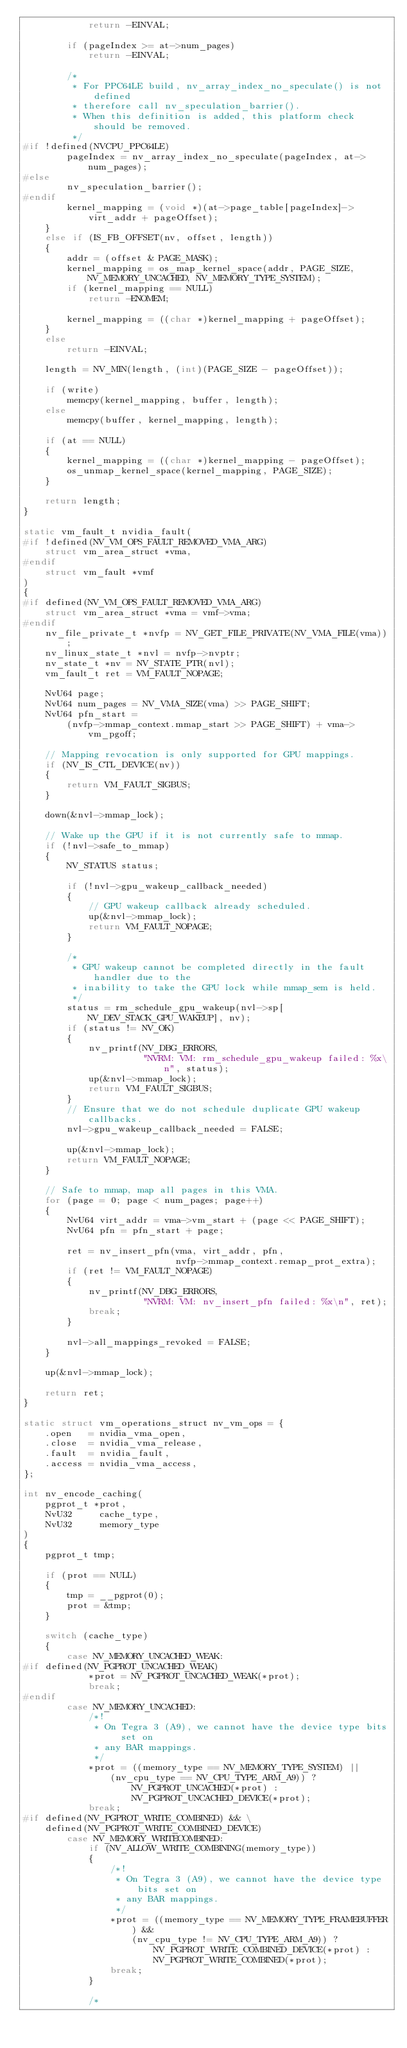Convert code to text. <code><loc_0><loc_0><loc_500><loc_500><_C_>            return -EINVAL;

        if (pageIndex >= at->num_pages)
            return -EINVAL;

        /*
         * For PPC64LE build, nv_array_index_no_speculate() is not defined
         * therefore call nv_speculation_barrier().
         * When this definition is added, this platform check should be removed.
         */
#if !defined(NVCPU_PPC64LE)
        pageIndex = nv_array_index_no_speculate(pageIndex, at->num_pages);
#else
        nv_speculation_barrier();
#endif
        kernel_mapping = (void *)(at->page_table[pageIndex]->virt_addr + pageOffset);
    }
    else if (IS_FB_OFFSET(nv, offset, length))
    {
        addr = (offset & PAGE_MASK);
        kernel_mapping = os_map_kernel_space(addr, PAGE_SIZE, NV_MEMORY_UNCACHED, NV_MEMORY_TYPE_SYSTEM);
        if (kernel_mapping == NULL)
            return -ENOMEM;

        kernel_mapping = ((char *)kernel_mapping + pageOffset);
    }
    else
        return -EINVAL;

    length = NV_MIN(length, (int)(PAGE_SIZE - pageOffset));

    if (write)
        memcpy(kernel_mapping, buffer, length);
    else
        memcpy(buffer, kernel_mapping, length);

    if (at == NULL)
    {
        kernel_mapping = ((char *)kernel_mapping - pageOffset);
        os_unmap_kernel_space(kernel_mapping, PAGE_SIZE);
    }

    return length;
}

static vm_fault_t nvidia_fault(
#if !defined(NV_VM_OPS_FAULT_REMOVED_VMA_ARG)
    struct vm_area_struct *vma,
#endif
    struct vm_fault *vmf
)
{
#if defined(NV_VM_OPS_FAULT_REMOVED_VMA_ARG)
    struct vm_area_struct *vma = vmf->vma;
#endif
    nv_file_private_t *nvfp = NV_GET_FILE_PRIVATE(NV_VMA_FILE(vma));
    nv_linux_state_t *nvl = nvfp->nvptr;
    nv_state_t *nv = NV_STATE_PTR(nvl);
    vm_fault_t ret = VM_FAULT_NOPAGE;

    NvU64 page;
    NvU64 num_pages = NV_VMA_SIZE(vma) >> PAGE_SHIFT;
    NvU64 pfn_start =
        (nvfp->mmap_context.mmap_start >> PAGE_SHIFT) + vma->vm_pgoff;

    // Mapping revocation is only supported for GPU mappings.
    if (NV_IS_CTL_DEVICE(nv))
    {
        return VM_FAULT_SIGBUS;
    }

    down(&nvl->mmap_lock);

    // Wake up the GPU if it is not currently safe to mmap.
    if (!nvl->safe_to_mmap)
    {
        NV_STATUS status;

        if (!nvl->gpu_wakeup_callback_needed)
        {
            // GPU wakeup callback already scheduled.
            up(&nvl->mmap_lock);
            return VM_FAULT_NOPAGE;
        }

        /*
         * GPU wakeup cannot be completed directly in the fault handler due to the
         * inability to take the GPU lock while mmap_sem is held.
         */
        status = rm_schedule_gpu_wakeup(nvl->sp[NV_DEV_STACK_GPU_WAKEUP], nv);
        if (status != NV_OK)
        {
            nv_printf(NV_DBG_ERRORS,
                      "NVRM: VM: rm_schedule_gpu_wakeup failed: %x\n", status);
            up(&nvl->mmap_lock);
            return VM_FAULT_SIGBUS;
        }
        // Ensure that we do not schedule duplicate GPU wakeup callbacks.
        nvl->gpu_wakeup_callback_needed = FALSE;

        up(&nvl->mmap_lock);
        return VM_FAULT_NOPAGE;
    }

    // Safe to mmap, map all pages in this VMA.
    for (page = 0; page < num_pages; page++)
    {
        NvU64 virt_addr = vma->vm_start + (page << PAGE_SHIFT);
        NvU64 pfn = pfn_start + page;

        ret = nv_insert_pfn(vma, virt_addr, pfn,
                            nvfp->mmap_context.remap_prot_extra);
        if (ret != VM_FAULT_NOPAGE)
        {
            nv_printf(NV_DBG_ERRORS,
                      "NVRM: VM: nv_insert_pfn failed: %x\n", ret);
            break;
        }

        nvl->all_mappings_revoked = FALSE;
    }

    up(&nvl->mmap_lock);

    return ret;
}

static struct vm_operations_struct nv_vm_ops = {
    .open   = nvidia_vma_open,
    .close  = nvidia_vma_release,
    .fault  = nvidia_fault,
    .access = nvidia_vma_access,
};

int nv_encode_caching(
    pgprot_t *prot,
    NvU32     cache_type,
    NvU32     memory_type
)
{
    pgprot_t tmp;

    if (prot == NULL)
    {
        tmp = __pgprot(0);
        prot = &tmp;
    }

    switch (cache_type)
    {
        case NV_MEMORY_UNCACHED_WEAK:
#if defined(NV_PGPROT_UNCACHED_WEAK)
            *prot = NV_PGPROT_UNCACHED_WEAK(*prot);
            break;
#endif
        case NV_MEMORY_UNCACHED:
            /*!
             * On Tegra 3 (A9), we cannot have the device type bits set on
             * any BAR mappings.
             */
            *prot = ((memory_type == NV_MEMORY_TYPE_SYSTEM) ||
                (nv_cpu_type == NV_CPU_TYPE_ARM_A9)) ?
                    NV_PGPROT_UNCACHED(*prot) :
                    NV_PGPROT_UNCACHED_DEVICE(*prot);
            break;
#if defined(NV_PGPROT_WRITE_COMBINED) && \
    defined(NV_PGPROT_WRITE_COMBINED_DEVICE)
        case NV_MEMORY_WRITECOMBINED:
            if (NV_ALLOW_WRITE_COMBINING(memory_type))
            {
                /*!
                 * On Tegra 3 (A9), we cannot have the device type bits set on
                 * any BAR mappings.
                 */
                *prot = ((memory_type == NV_MEMORY_TYPE_FRAMEBUFFER) &&
                    (nv_cpu_type != NV_CPU_TYPE_ARM_A9)) ?
                        NV_PGPROT_WRITE_COMBINED_DEVICE(*prot) :
                        NV_PGPROT_WRITE_COMBINED(*prot);
                break;
            }

            /*</code> 